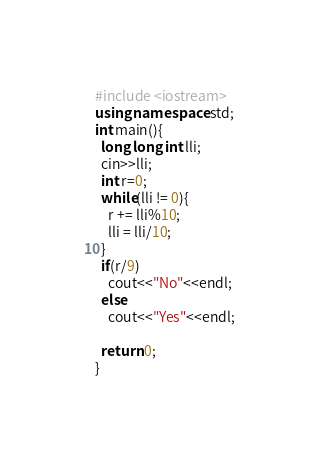<code> <loc_0><loc_0><loc_500><loc_500><_C++_>#include <iostream> 
using namespace std;
int main(){
  long long int lli;
  cin>>lli;
  int r=0;
  while(lli != 0){
    r += lli%10;
    lli = lli/10;
  }
  if(r/9)
    cout<<"No"<<endl;
  else
    cout<<"Yes"<<endl;
  
  return 0;
}</code> 